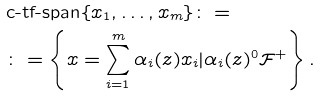Convert formula to latex. <formula><loc_0><loc_0><loc_500><loc_500>& \text {c-tf-span} \{ x _ { 1 } , \dots , x _ { m } \} \colon = \\ & \colon = \left \{ x = \sum _ { i = 1 } ^ { m } \alpha _ { i } ( z ) x _ { i } | \alpha _ { i } ( z ) ^ { 0 } \mathcal { F } ^ { + } \right \} .</formula> 